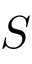<formula> <loc_0><loc_0><loc_500><loc_500>S</formula> 